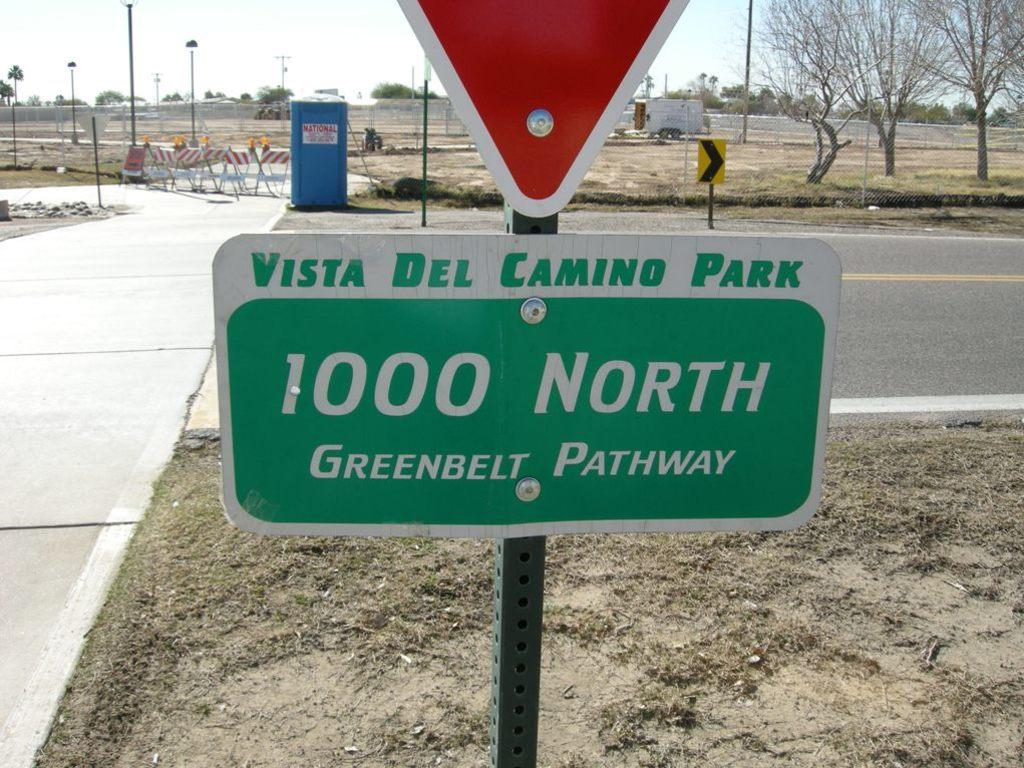<image>
Render a clear and concise summary of the photo. A small green and white sign is below the tip of a yield sign that reads vista del camino park. 